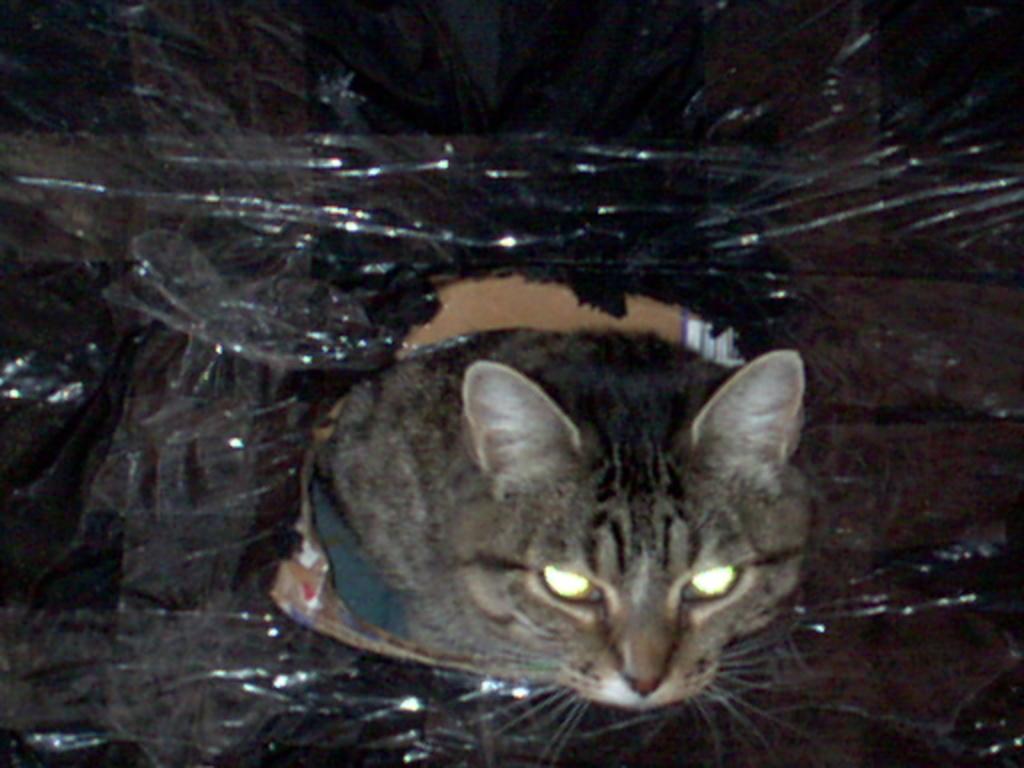Could you give a brief overview of what you see in this image? In this image I can see a cat. Here I can see some black color thing. 